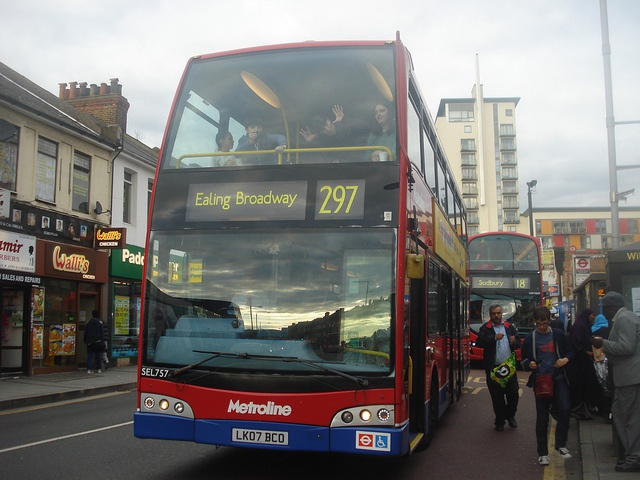Describe the objects in this image and their specific colors. I can see bus in lightgray, gray, black, and darkgray tones, bus in lightgray, gray, black, and purple tones, people in lightgray, black, maroon, and gray tones, people in lightgray, black, and gray tones, and people in lightgray, black, gray, darkgreen, and maroon tones in this image. 